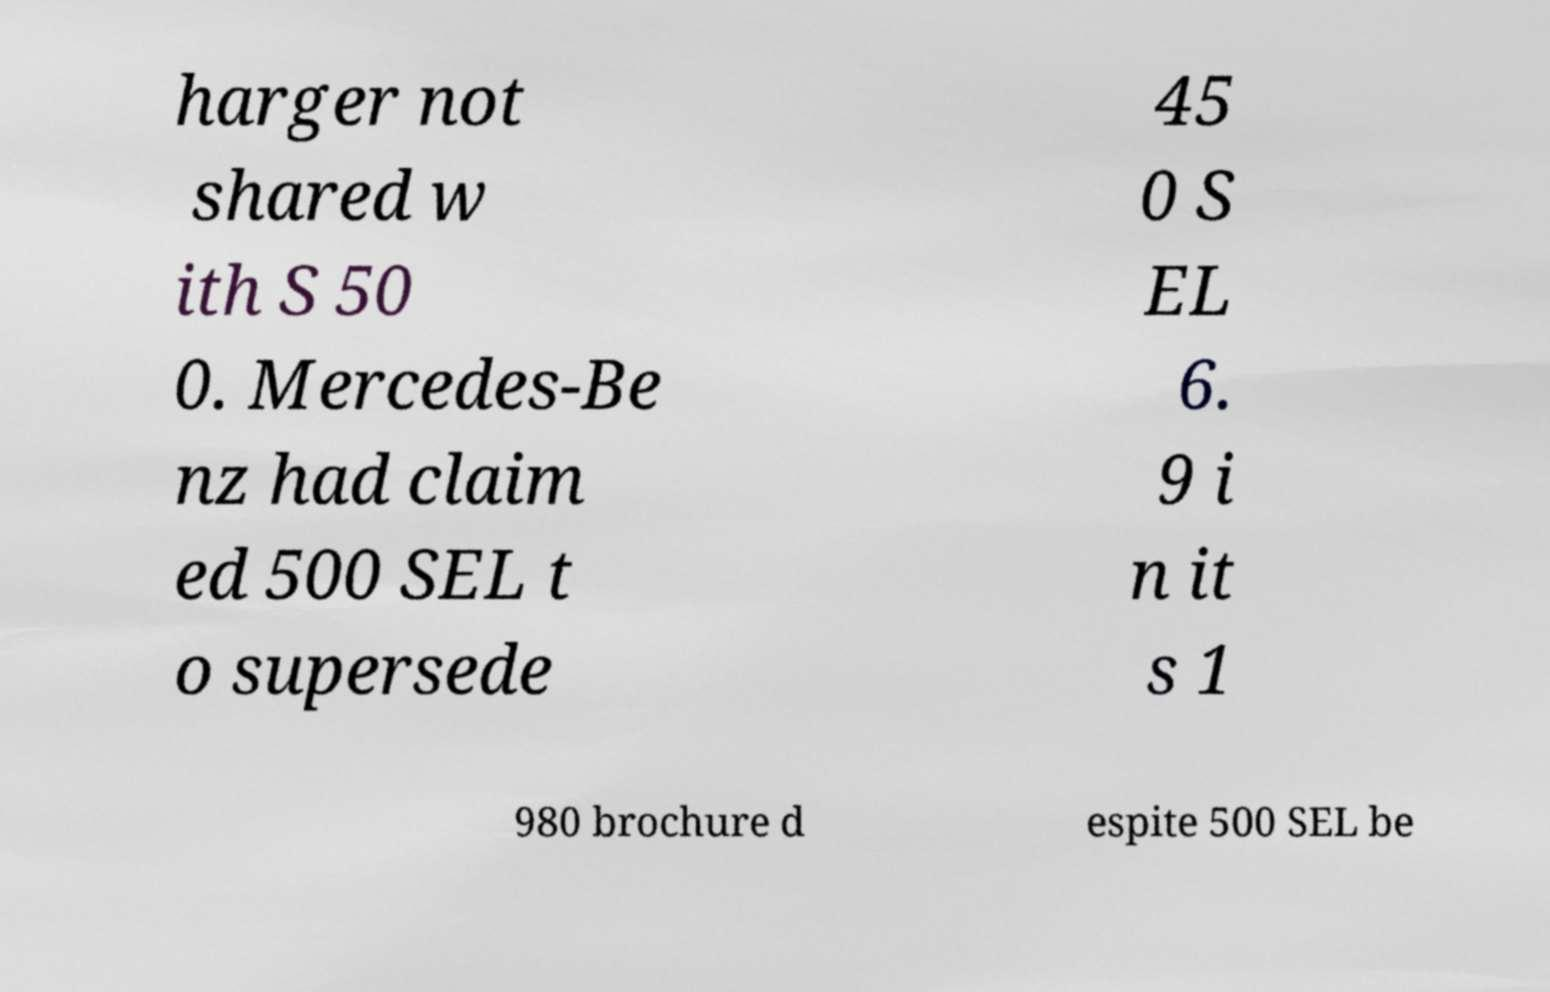I need the written content from this picture converted into text. Can you do that? harger not shared w ith S 50 0. Mercedes-Be nz had claim ed 500 SEL t o supersede 45 0 S EL 6. 9 i n it s 1 980 brochure d espite 500 SEL be 